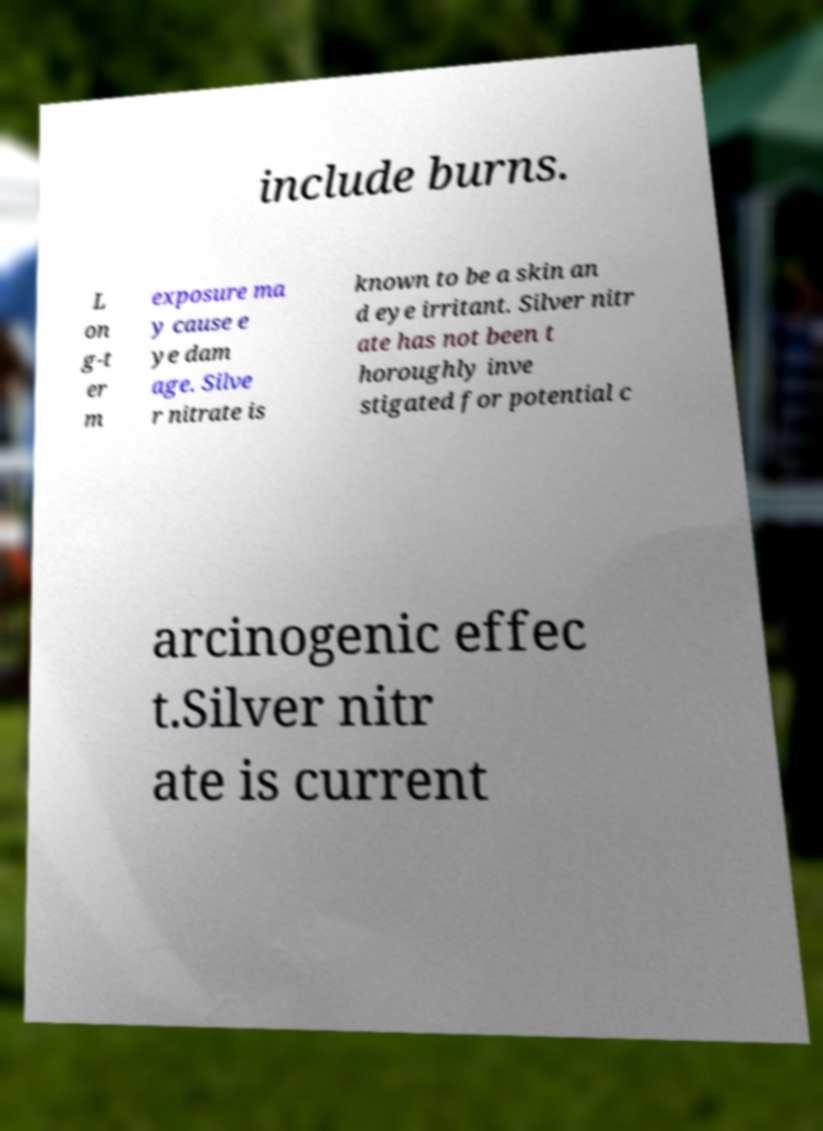Could you assist in decoding the text presented in this image and type it out clearly? include burns. L on g-t er m exposure ma y cause e ye dam age. Silve r nitrate is known to be a skin an d eye irritant. Silver nitr ate has not been t horoughly inve stigated for potential c arcinogenic effec t.Silver nitr ate is current 